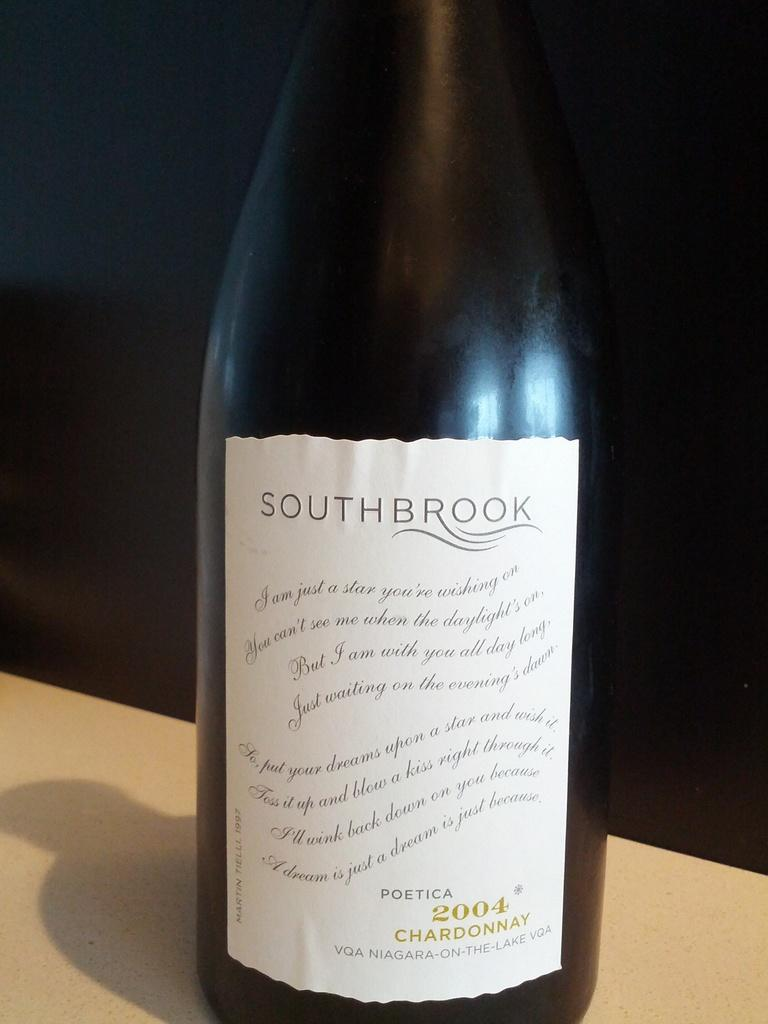Provide a one-sentence caption for the provided image. Southbrook Chardonnay Wine made in 2004 from Niagara on the Lake. 